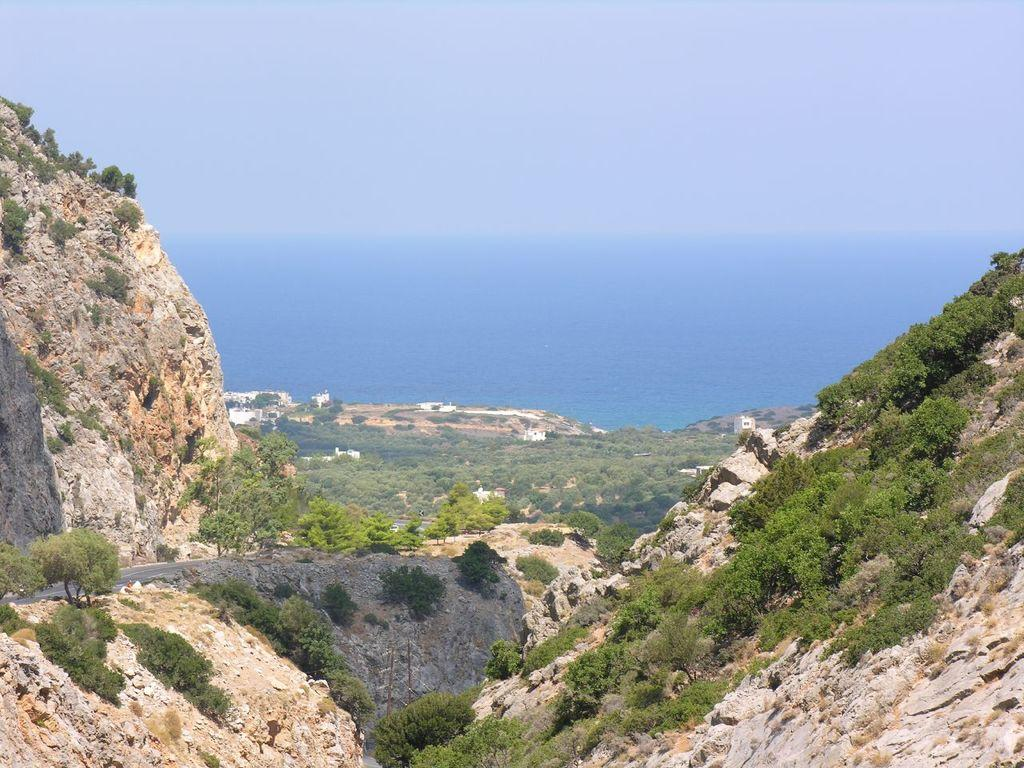What type of natural elements can be seen in the front of the image? There are rocks in the front of the image. What other natural elements are present in the image? There are plants visible in the image. What can be seen in the background of the image? There are trees and an ocean visible in the background of the image. Can you see your uncle holding a bone in the image? There is no uncle or bone present in the image. What type of hand gesture is being made by the plants in the image? Plants do not have the ability to make hand gestures, as they are not living organisms with hands. 